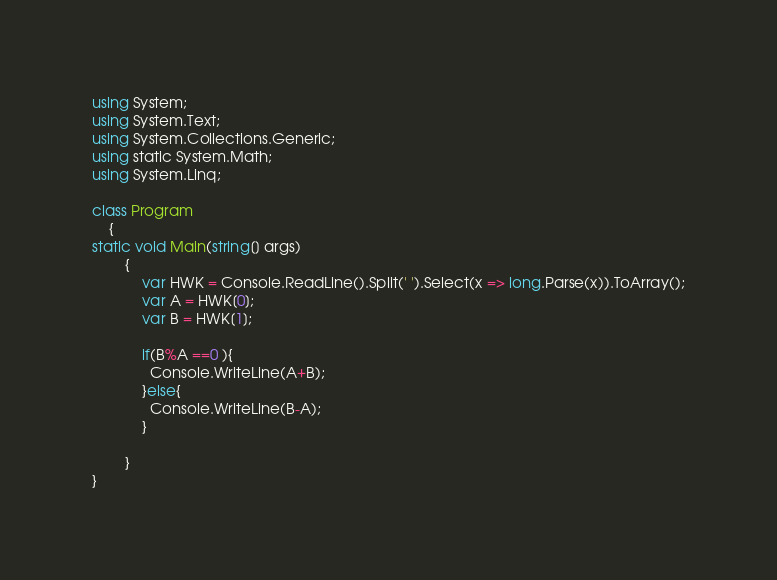<code> <loc_0><loc_0><loc_500><loc_500><_C#_>using System;
using System.Text;
using System.Collections.Generic;
using static System.Math;
using System.Linq;

class Program
    {
static void Main(string[] args)
        {
            var HWK = Console.ReadLine().Split(' ').Select(x => long.Parse(x)).ToArray();
            var A = HWK[0];
            var B = HWK[1];
            
            if(B%A ==0 ){
              Console.WriteLine(A+B);
            }else{
              Console.WriteLine(B-A);
            }
            
        }
}
</code> 